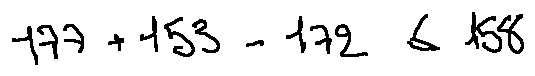<formula> <loc_0><loc_0><loc_500><loc_500>1 7 7 + 1 5 3 - 1 7 2 \leq 1 5 8</formula> 